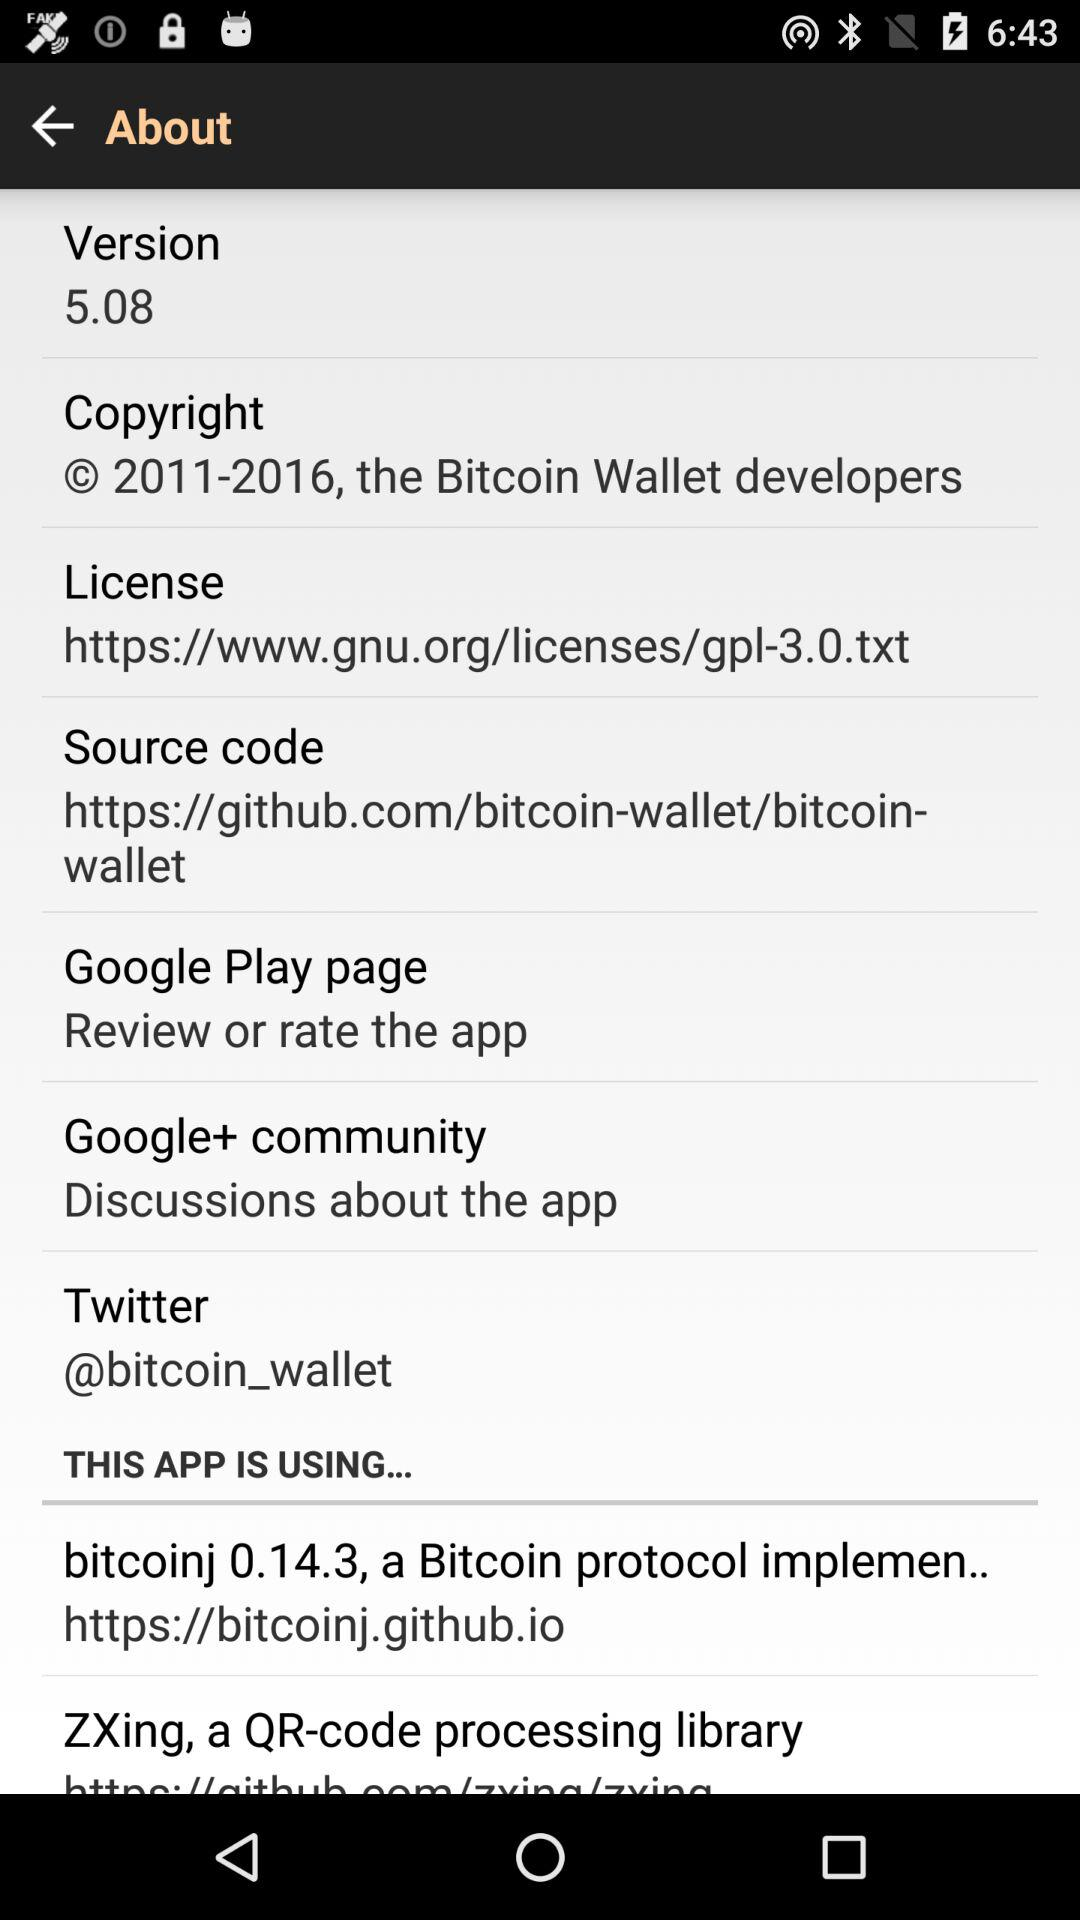Where can I rate the application? You can rate the application on the Google Play page. 